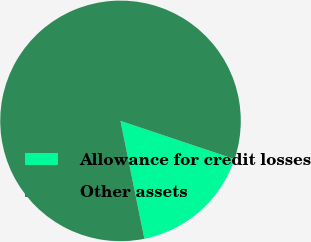Convert chart to OTSL. <chart><loc_0><loc_0><loc_500><loc_500><pie_chart><fcel>Allowance for credit losses<fcel>Other assets<nl><fcel>16.67%<fcel>83.33%<nl></chart> 